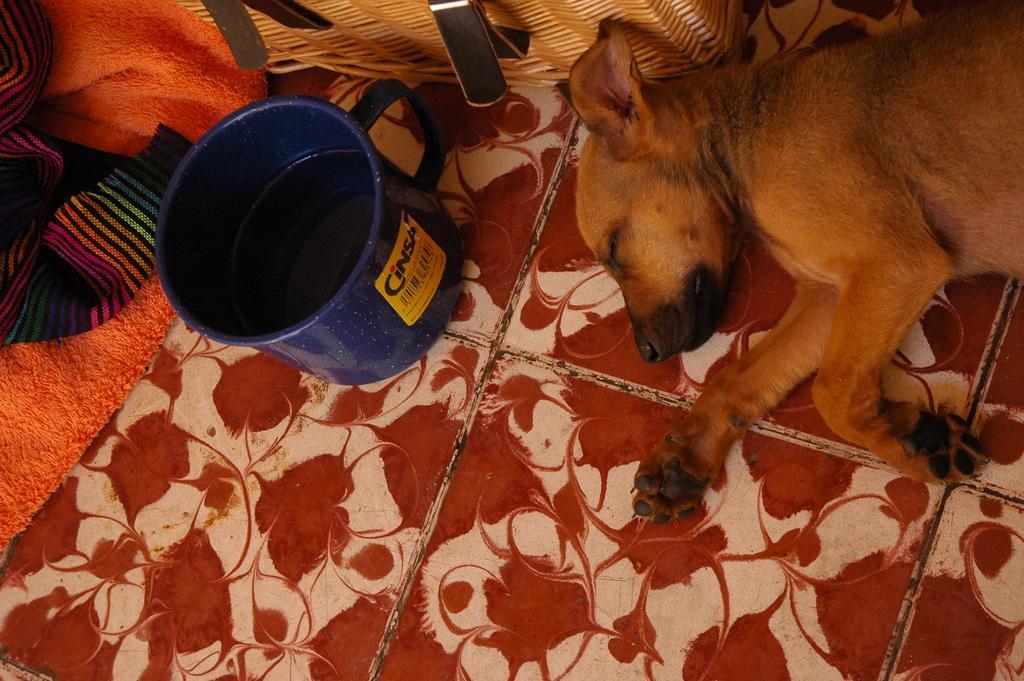Can you describe this image briefly? In this picture we can see a dog is lying on the floor, beside the dog we can see few clothes and water in the tub. 